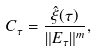<formula> <loc_0><loc_0><loc_500><loc_500>C _ { \tau } = \frac { \hat { \xi } ( \tau ) } { \| E _ { \tau } \| ^ { m } } ,</formula> 